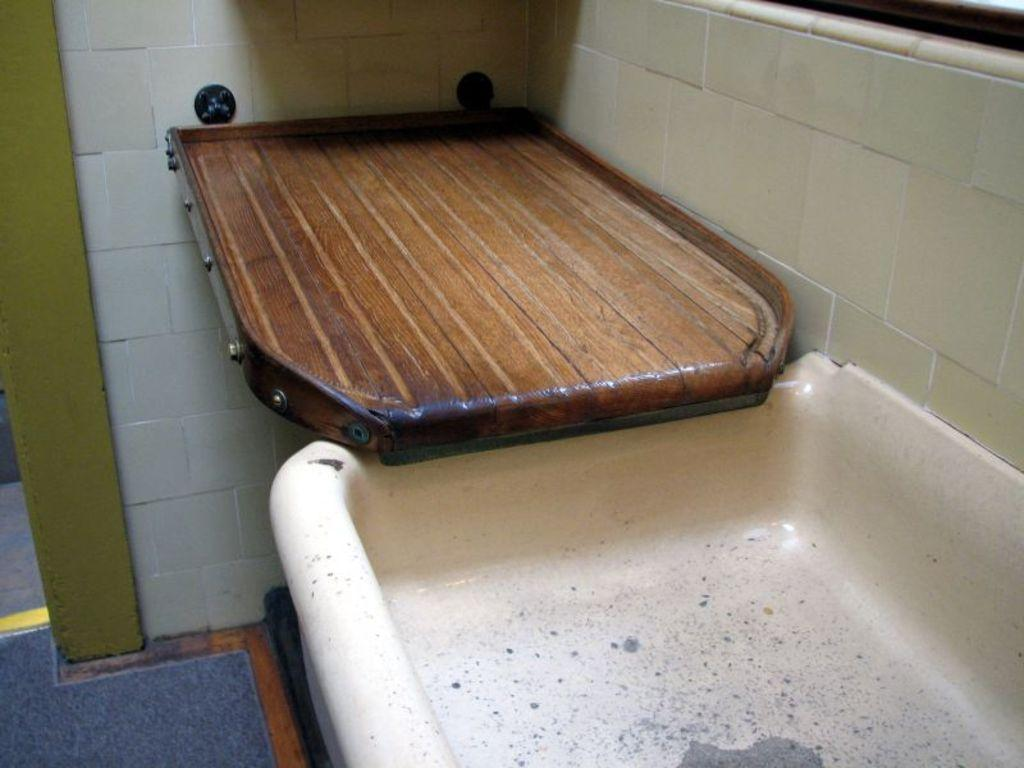What is the main object in the center of the image? There is a wash basin in the center of the image. What other object can be seen in the image? There is a wooden board in the image. What is visible in the background of the image? There is a wall in the background of the image. What type of quiver can be seen hanging on the wall in the image? There is no quiver present in the image; it only features a wash basin and a wooden board. What animal can be seen interacting with the wash basin in the image? There are no animals present in the image; it only features a wash basin and a wooden board. 